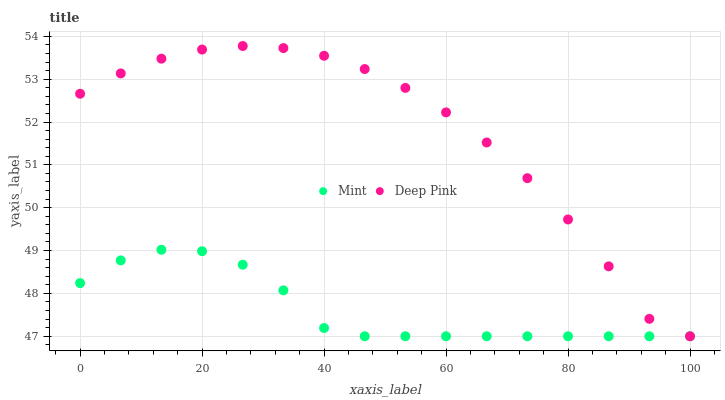Does Mint have the minimum area under the curve?
Answer yes or no. Yes. Does Deep Pink have the maximum area under the curve?
Answer yes or no. Yes. Does Mint have the maximum area under the curve?
Answer yes or no. No. Is Mint the smoothest?
Answer yes or no. Yes. Is Deep Pink the roughest?
Answer yes or no. Yes. Is Mint the roughest?
Answer yes or no. No. Does Deep Pink have the lowest value?
Answer yes or no. Yes. Does Deep Pink have the highest value?
Answer yes or no. Yes. Does Mint have the highest value?
Answer yes or no. No. Does Mint intersect Deep Pink?
Answer yes or no. Yes. Is Mint less than Deep Pink?
Answer yes or no. No. Is Mint greater than Deep Pink?
Answer yes or no. No. 